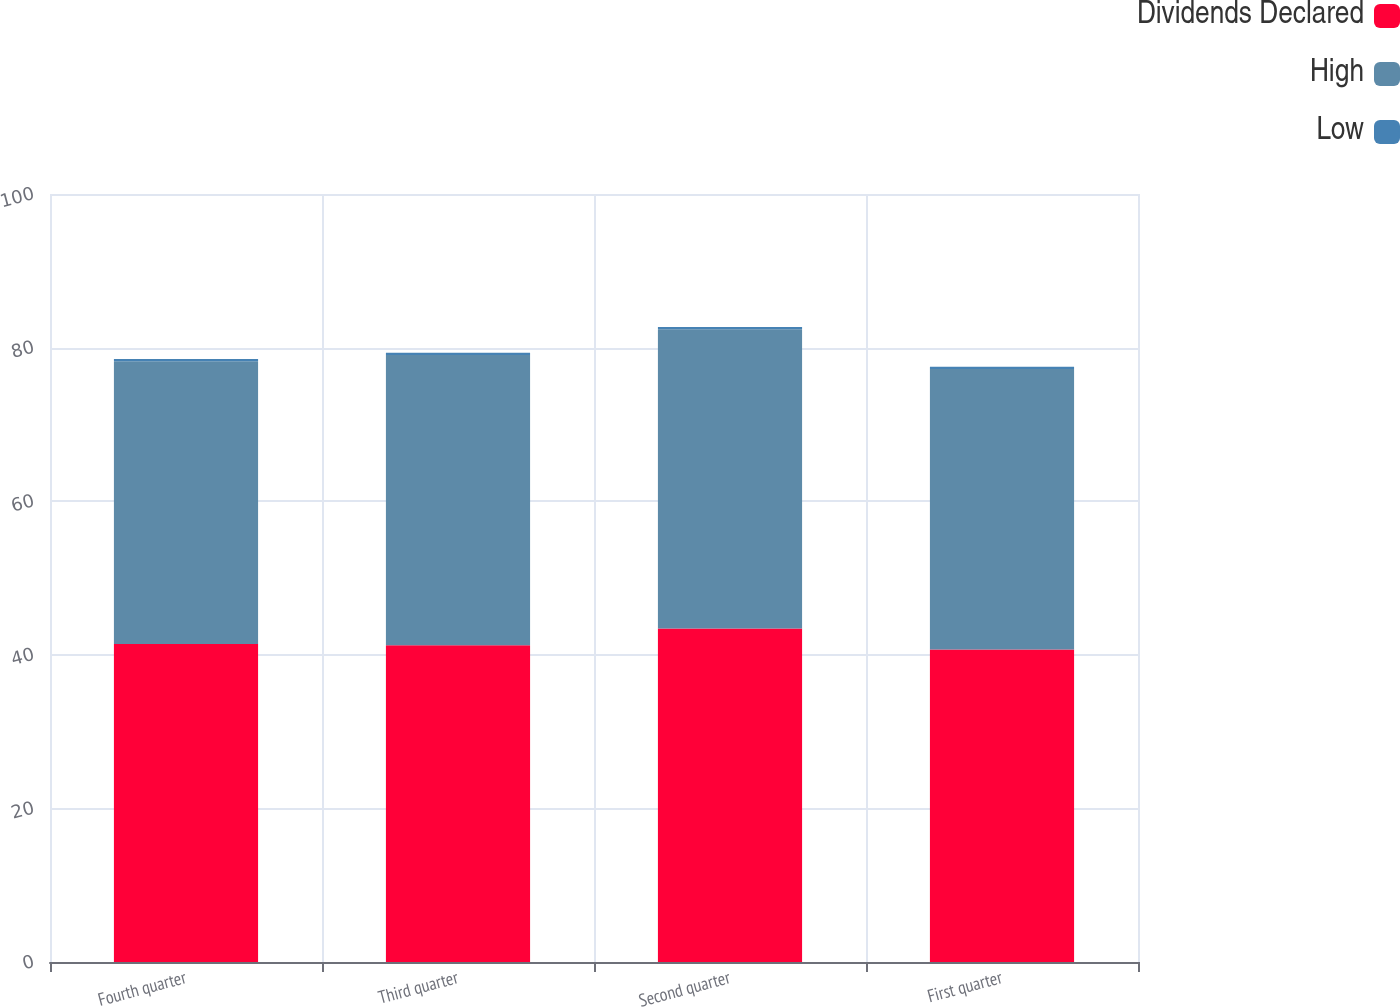Convert chart to OTSL. <chart><loc_0><loc_0><loc_500><loc_500><stacked_bar_chart><ecel><fcel>Fourth quarter<fcel>Third quarter<fcel>Second quarter<fcel>First quarter<nl><fcel>Dividends Declared<fcel>41.39<fcel>41.25<fcel>43.43<fcel>40.7<nl><fcel>High<fcel>36.83<fcel>37.8<fcel>38.97<fcel>36.52<nl><fcel>Low<fcel>0.28<fcel>0.28<fcel>0.28<fcel>0.28<nl></chart> 